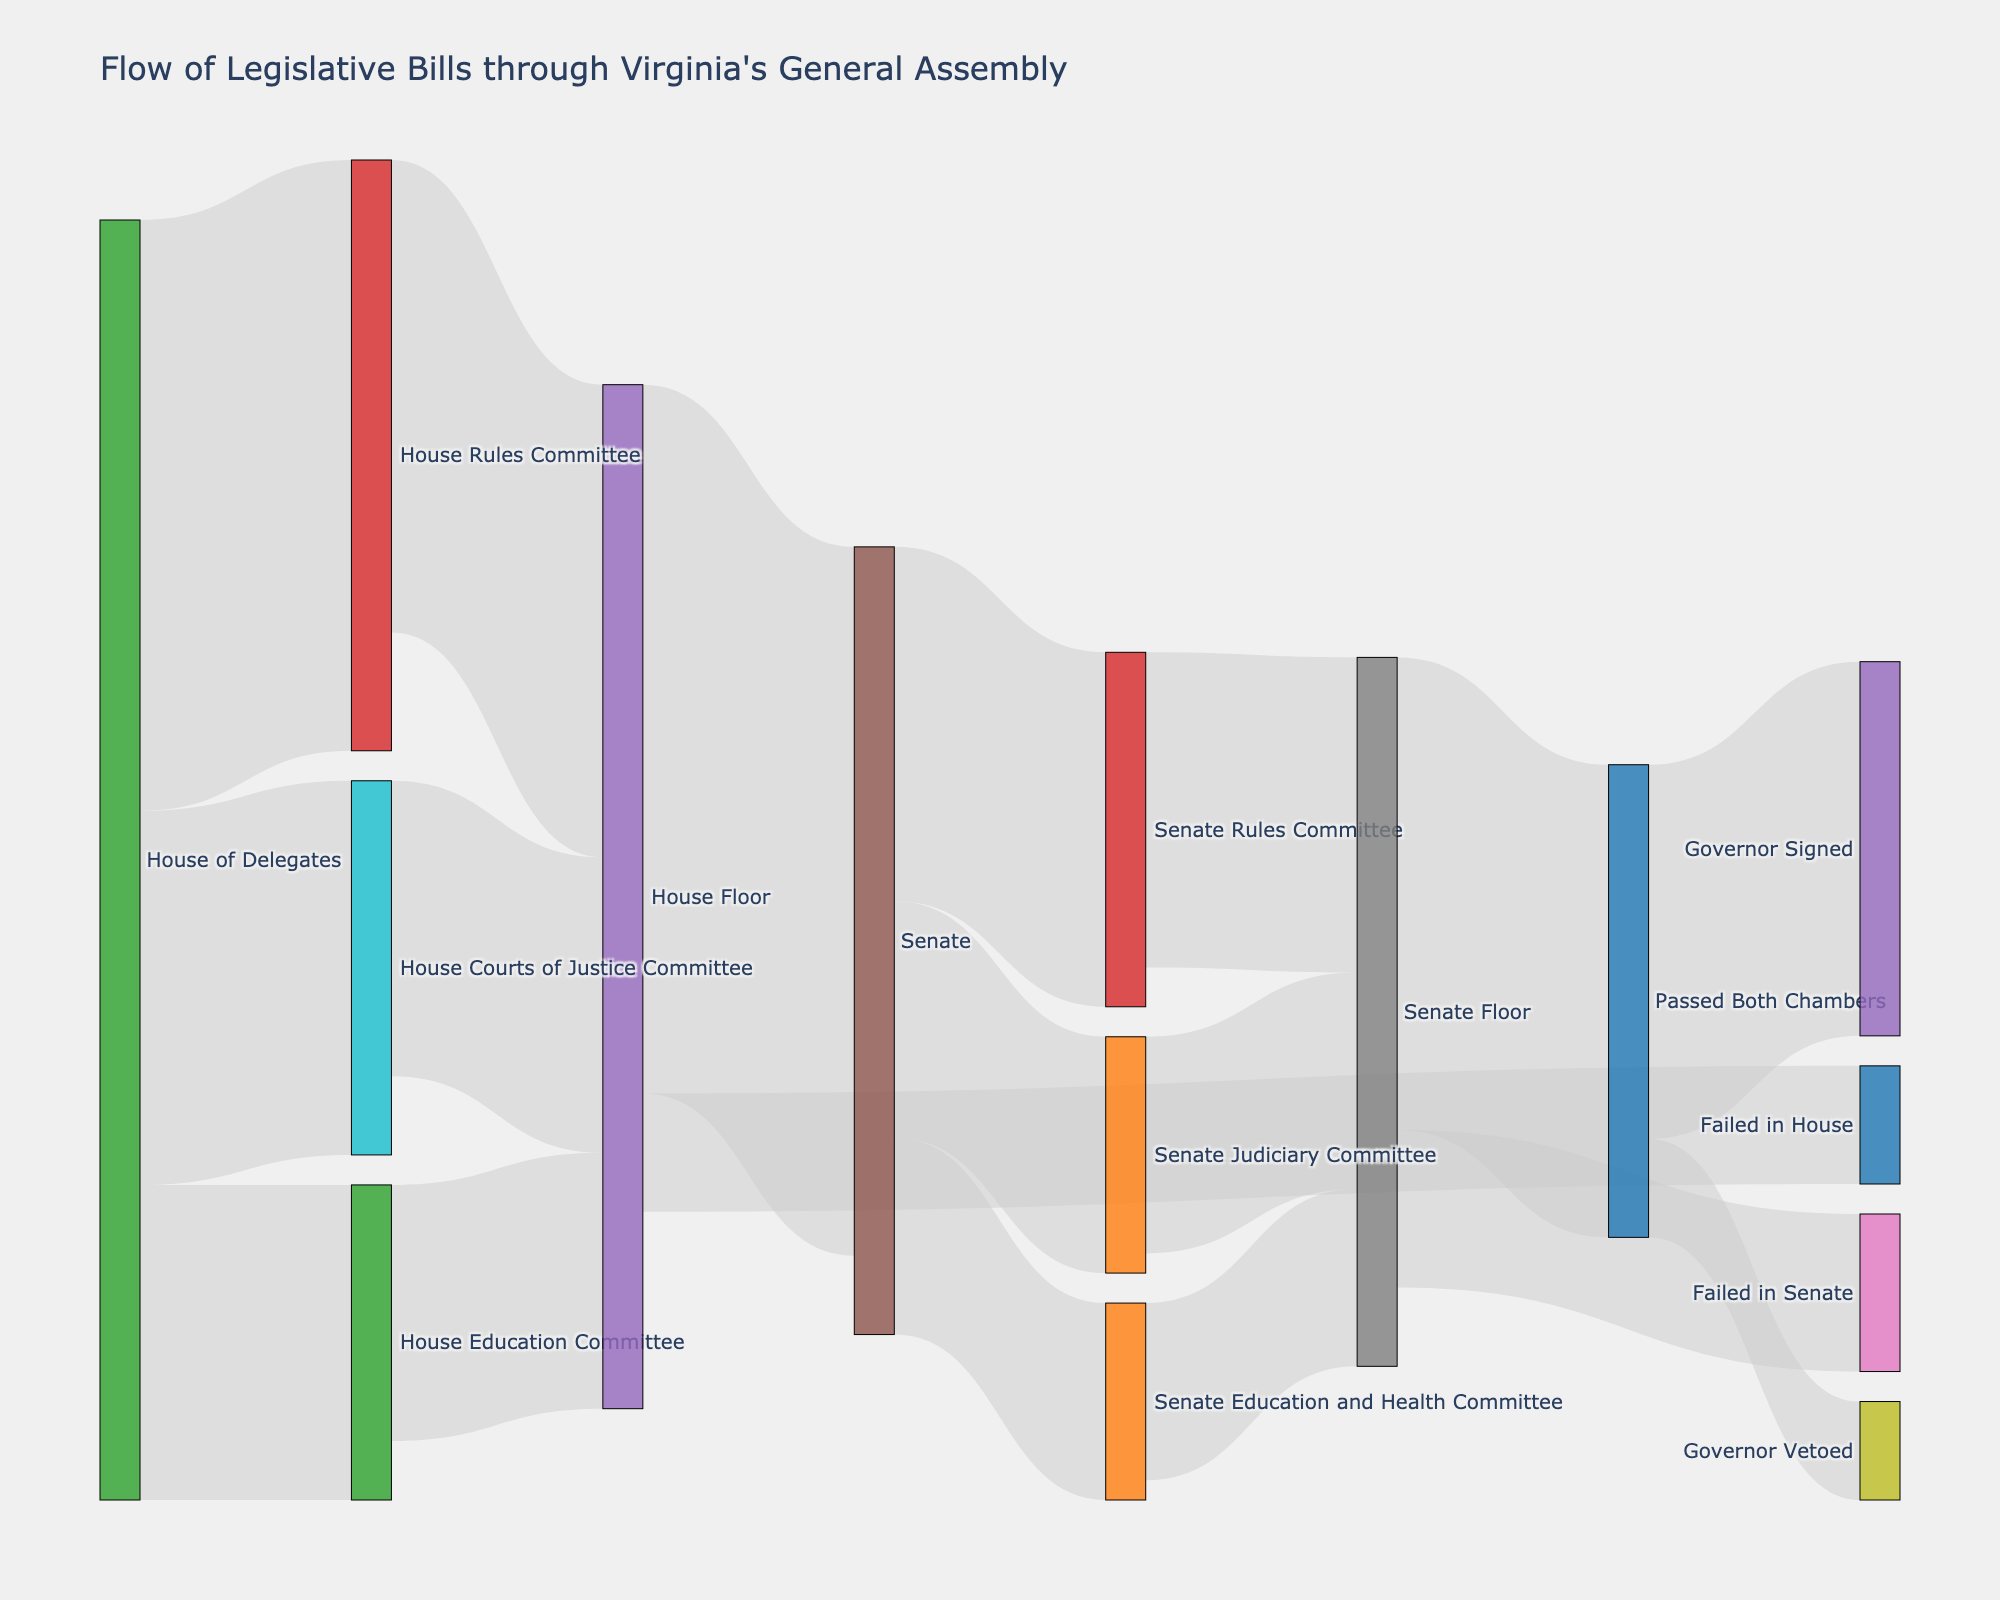Which source node has the most connections to other nodes? The House of Delegates has the most connections to other nodes according to the figure. It has links to the House Rules Committee, House Courts of Justice Committee, and House Education Committee.
Answer: The House of Delegates What percentage of bills from the House Rules Committee moved to the House Floor? The House Rules Committee passed 120 bills to the House Floor out of the 150 bills it received. The percentage is calculated as (120/150)*100%.
Answer: 80% How many bills failed in both the House and the Senate combined? The number of bills that failed in the House is 30, and the number of bills that failed in the Senate is 40. Adding these together gives us 30 + 40.
Answer: 70 How many bills were signed by the Governor? Bills passing both chambers that were signed by the Governor totaled 95 according to the flow from "Passed Both Chambers" to "Governor Signed".
Answer: 95 What is the total number of bills that originated in the Senate? Summing all the movements from the Senate to its committees, 90 + 60 + 50, gives the total.
Answer: 200 Compare the number of bills processed by the House Rules Committee and the Senate Rules Committee. Which is higher? The House Rules Committee processed 150 bills, whereas the Senate Rules Committee processed 90 bills. 150 is higher than 90.
Answer: House Rules Committee How many bills originated in the House of Delegates and directly moved to the House Floor? The number of bills that directly moved to the House Floor from the House Rules Committee, House Courts of Justice Committee, and House Education Committee sums to 120 + 75 + 65.
Answer: 260 Which node has the highest outflow of bills? The node "House Floor" has the highest outflow with a total of summing 180 (to Senate) and 30 (Failed in House).
Answer: House Floor What is the difference between the bills that were passed by both chambers and the bills that the Governor vetoed? Bills passed by both chambers that were signed by the Governor are 95, and bills that were vetoed by the Governor are 25. The difference is 95 - 25.
Answer: 70 After bills pass both chambers, what is the ratio between those signed by the Governor and those vetoed? The ratio of bills signed by the Governor (95) to those vetoed (25) after passing both chambers is calculated as 95:25 which simplifies to 95/25 = 3.8:1.
Answer: 3.8:1 